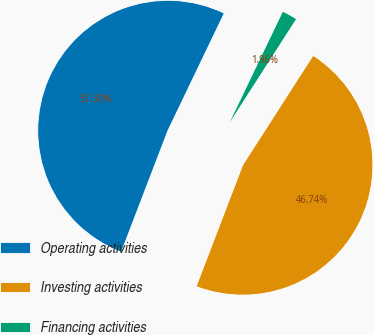Convert chart. <chart><loc_0><loc_0><loc_500><loc_500><pie_chart><fcel>Operating activities<fcel>Investing activities<fcel>Financing activities<nl><fcel>51.3%<fcel>46.74%<fcel>1.96%<nl></chart> 